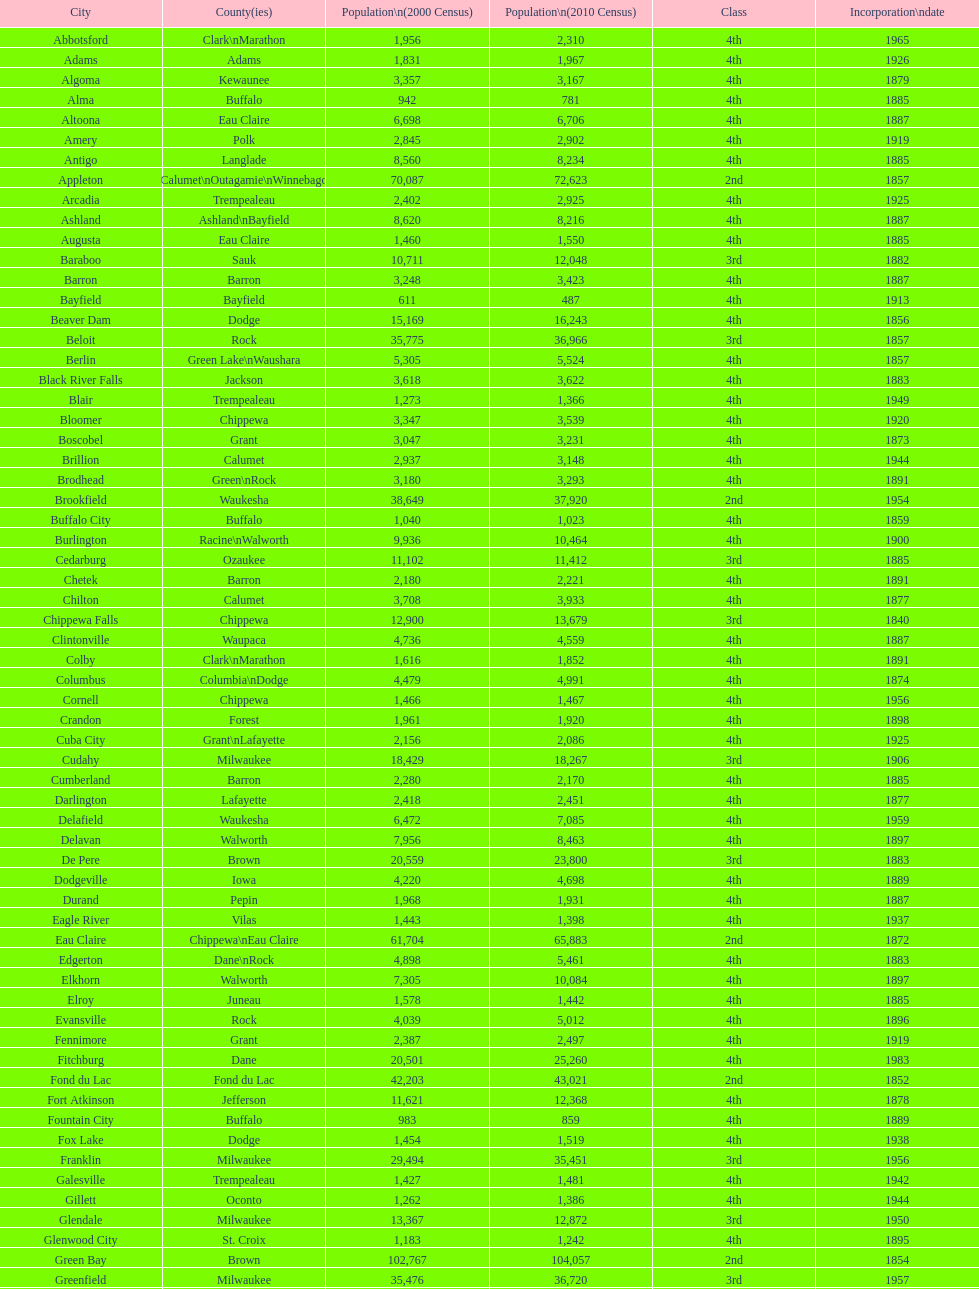Which city in wisconsin is the most populous, based on the 2010 census? Milwaukee. 